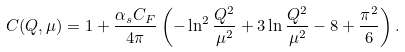<formula> <loc_0><loc_0><loc_500><loc_500>C ( Q , \mu ) = 1 + \frac { \alpha _ { s } C _ { F } } { 4 \pi } \left ( - \ln ^ { 2 } \frac { Q ^ { 2 } } { \mu ^ { 2 } } + 3 \ln \frac { Q ^ { 2 } } { \mu ^ { 2 } } - 8 + \frac { \pi ^ { 2 } } { 6 } \right ) .</formula> 